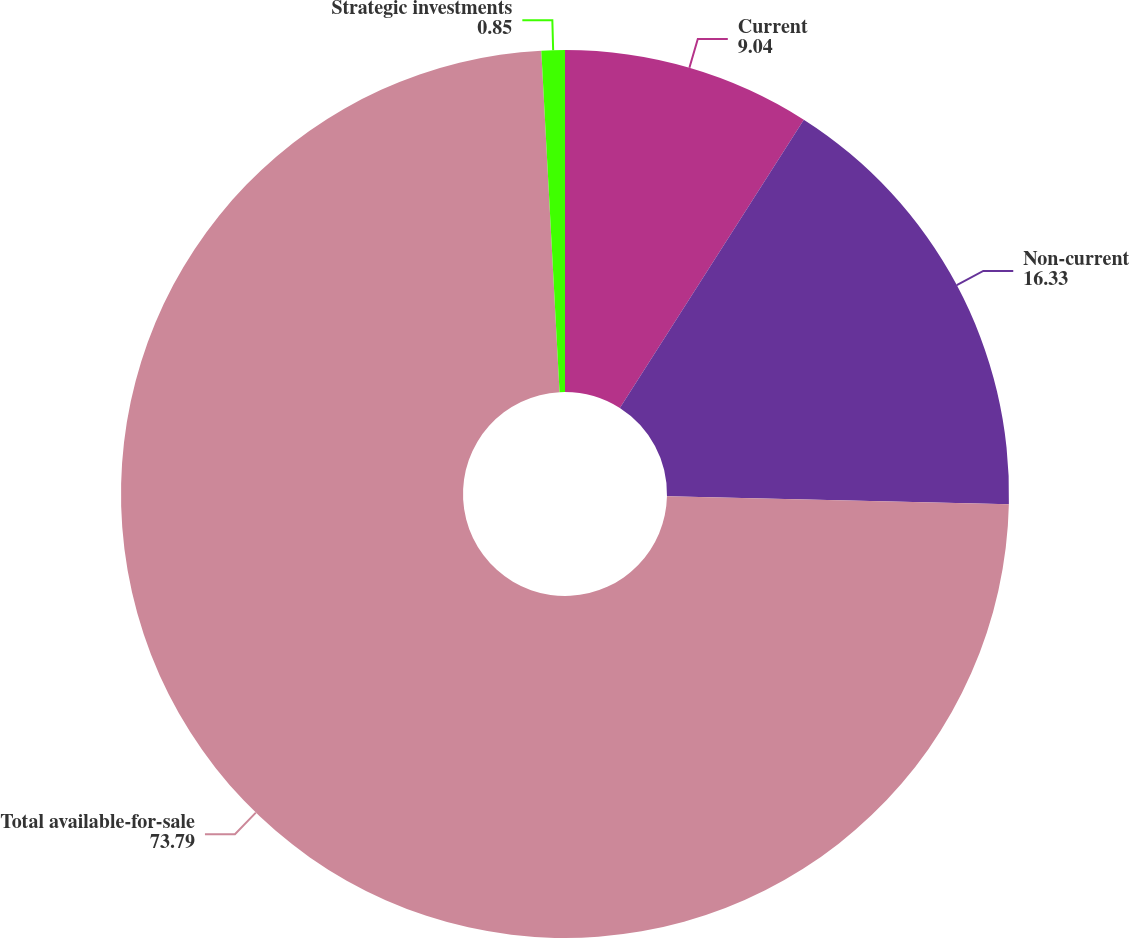Convert chart. <chart><loc_0><loc_0><loc_500><loc_500><pie_chart><fcel>Current<fcel>Non-current<fcel>Total available-for-sale<fcel>Strategic investments<nl><fcel>9.04%<fcel>16.33%<fcel>73.79%<fcel>0.85%<nl></chart> 